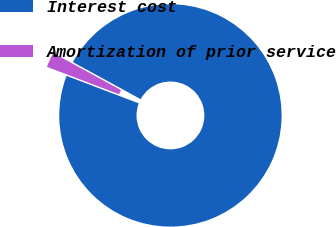Convert chart. <chart><loc_0><loc_0><loc_500><loc_500><pie_chart><fcel>Interest cost<fcel>Amortization of prior service<nl><fcel>97.83%<fcel>2.17%<nl></chart> 